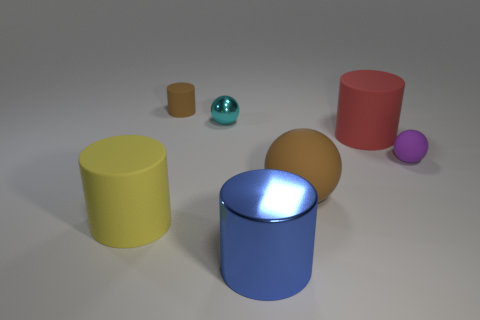What number of objects are either spheres that are behind the red rubber object or big balls?
Your answer should be compact. 2. The other object that is the same material as the blue object is what shape?
Give a very brief answer. Sphere. The large red rubber object has what shape?
Give a very brief answer. Cylinder. There is a cylinder that is both behind the large yellow thing and to the right of the small cyan shiny sphere; what is its color?
Make the answer very short. Red. The red object that is the same size as the yellow matte cylinder is what shape?
Offer a terse response. Cylinder. Are there any other rubber objects that have the same shape as the large yellow matte thing?
Provide a short and direct response. Yes. Are the small purple sphere and the large object on the left side of the blue metal cylinder made of the same material?
Offer a very short reply. Yes. The large matte cylinder that is to the right of the brown thing to the left of the small sphere to the left of the big rubber ball is what color?
Keep it short and to the point. Red. There is a yellow cylinder that is the same size as the blue cylinder; what is it made of?
Give a very brief answer. Rubber. What number of red cylinders have the same material as the small purple thing?
Your response must be concise. 1. 